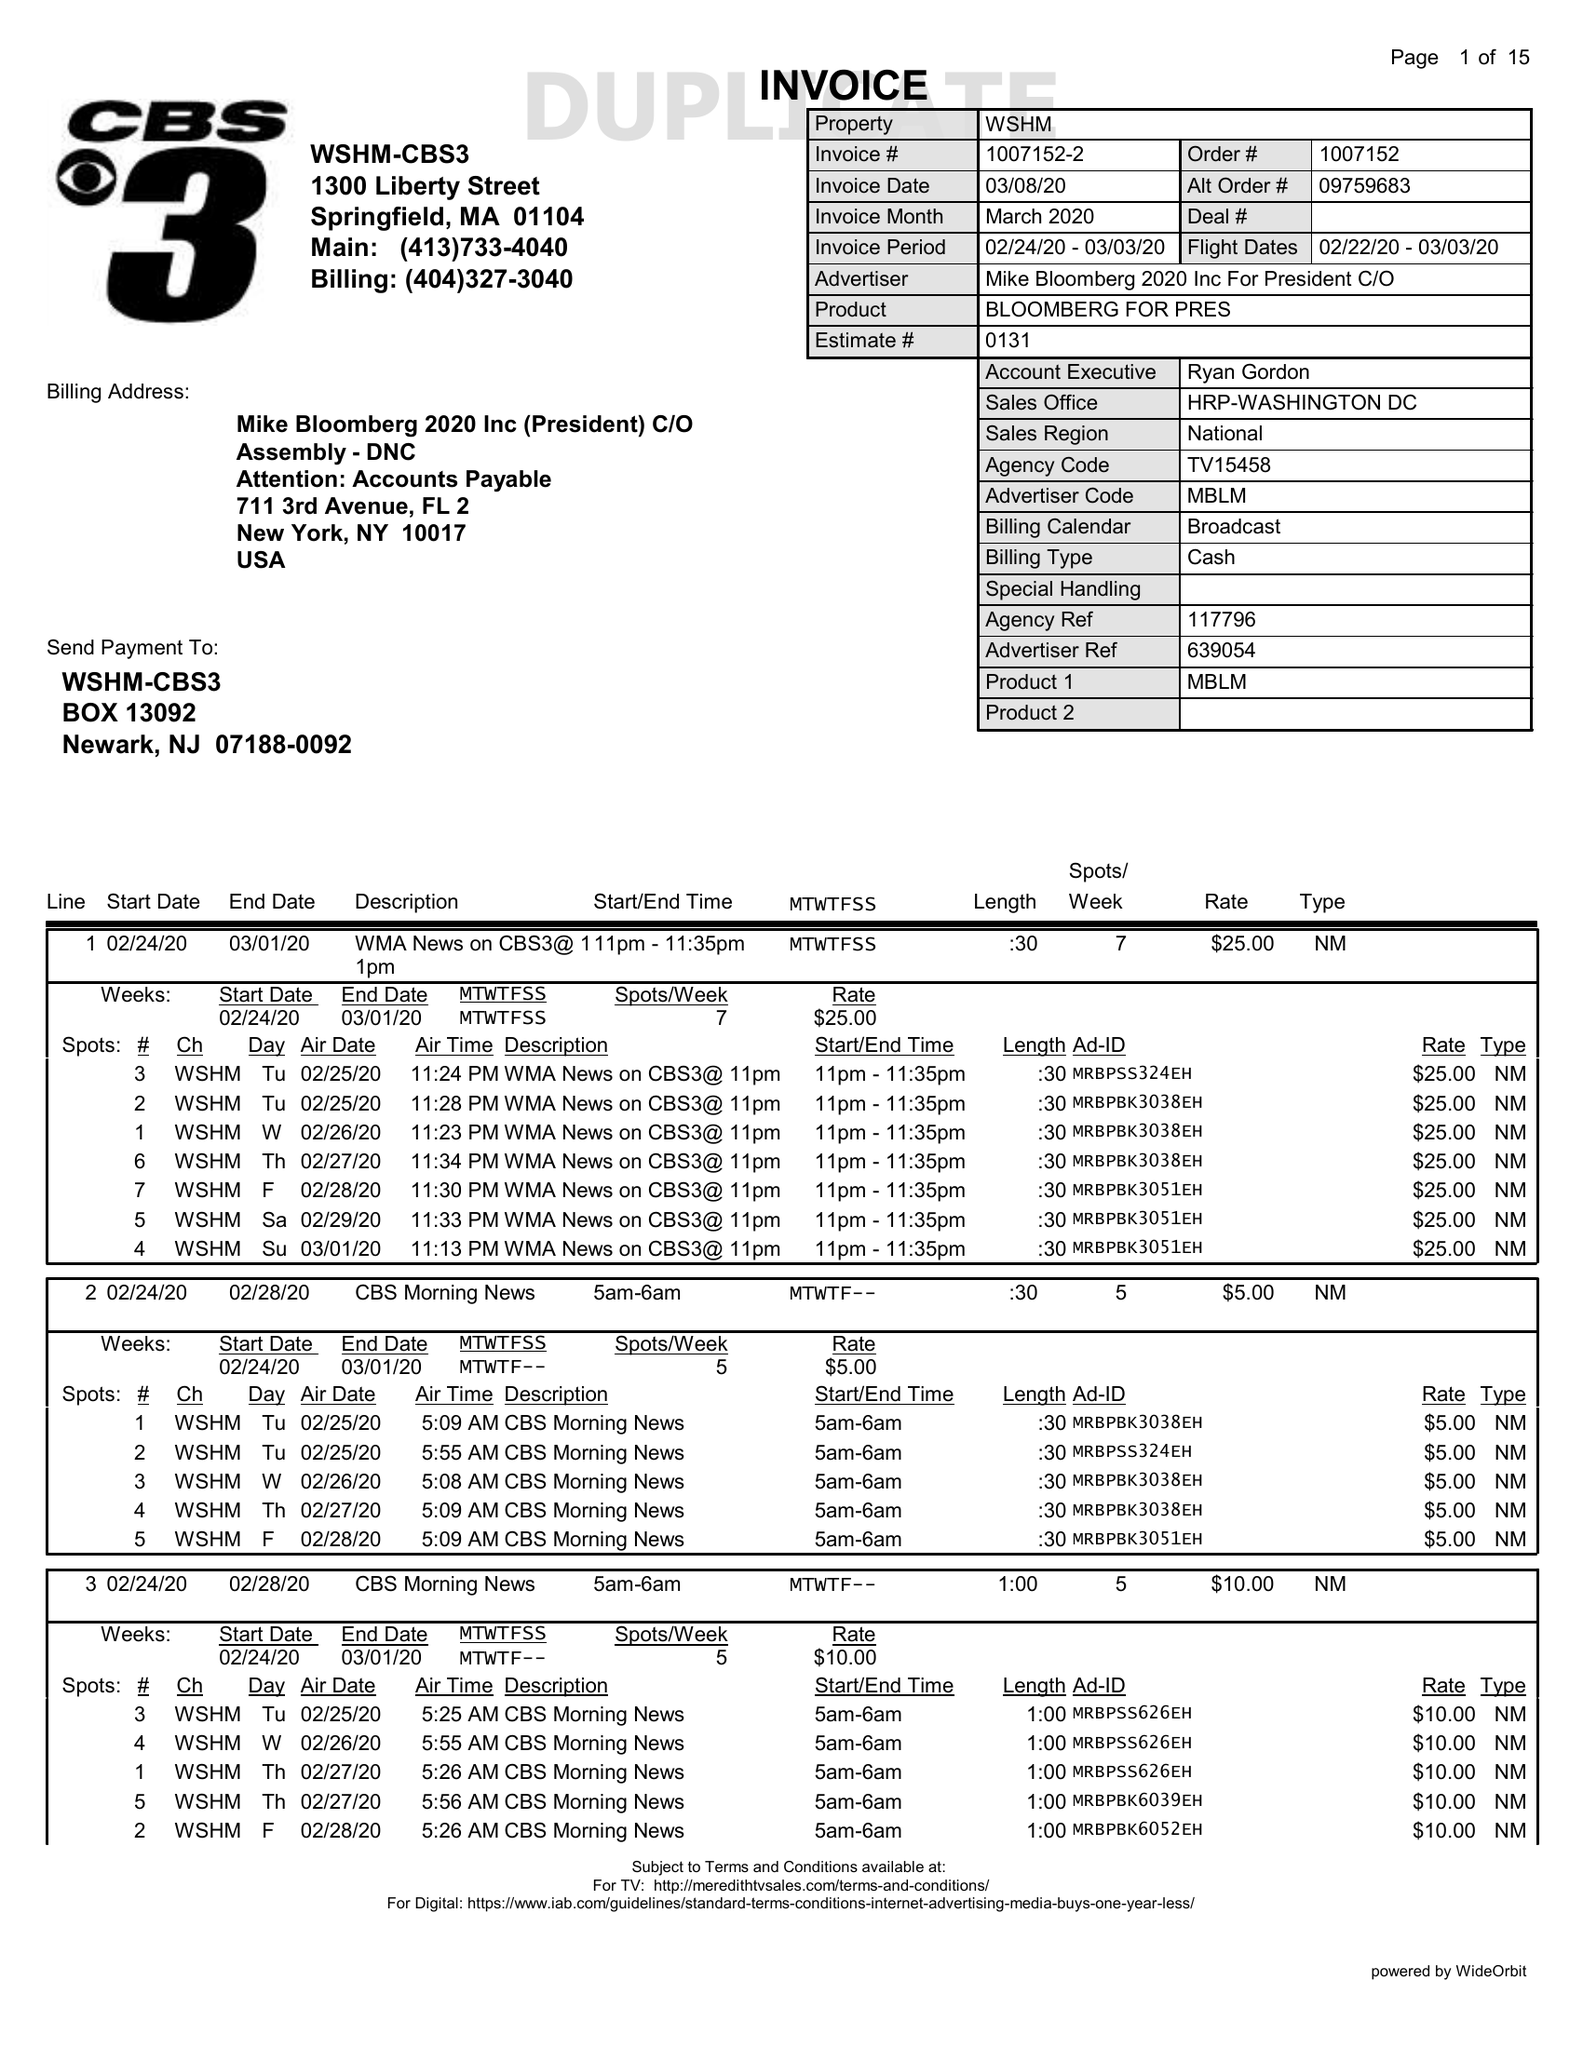What is the value for the flight_to?
Answer the question using a single word or phrase. 03/03/20 